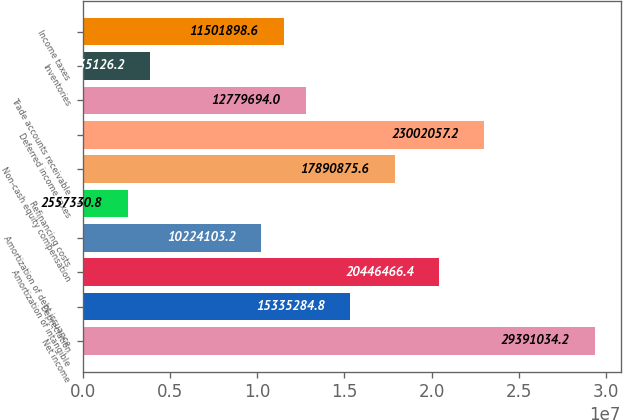Convert chart. <chart><loc_0><loc_0><loc_500><loc_500><bar_chart><fcel>Net income<fcel>Depreciation<fcel>Amortization of intangible<fcel>Amortization of debt issuance<fcel>Refinancing costs<fcel>Non-cash equity compensation<fcel>Deferred income taxes<fcel>Trade accounts receivable<fcel>Inventories<fcel>Income taxes<nl><fcel>2.9391e+07<fcel>1.53353e+07<fcel>2.04465e+07<fcel>1.02241e+07<fcel>2.55733e+06<fcel>1.78909e+07<fcel>2.30021e+07<fcel>1.27797e+07<fcel>3.83513e+06<fcel>1.15019e+07<nl></chart> 